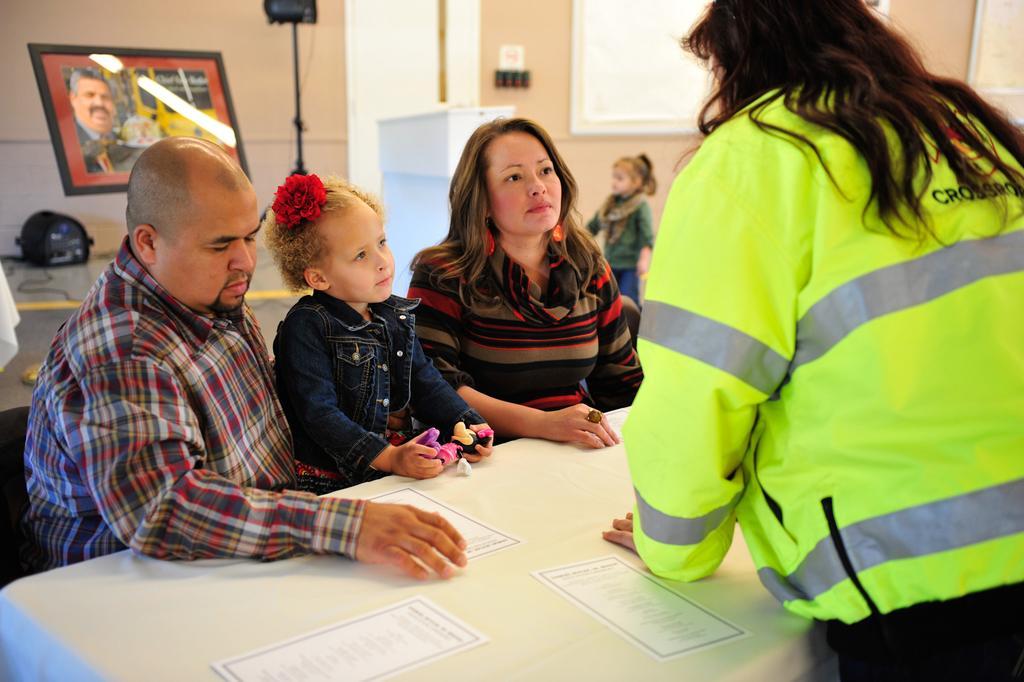Describe this image in one or two sentences. In this image we can see three people sitting in the chairs, a child is holding a doll in it. On the right side we can see a woman talking to them standing behind the table containing papers and a cloth on it. On the backside we can see a frame, table, wall and a child. 